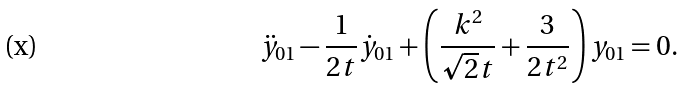<formula> <loc_0><loc_0><loc_500><loc_500>\ddot { y } _ { 0 1 } - \frac { 1 } { 2 t } \dot { y } _ { 0 1 } + \left ( \frac { k ^ { 2 } } { \sqrt { 2 } t } + \frac { 3 } { 2 t ^ { 2 } } \right ) y _ { 0 1 } = 0 .</formula> 